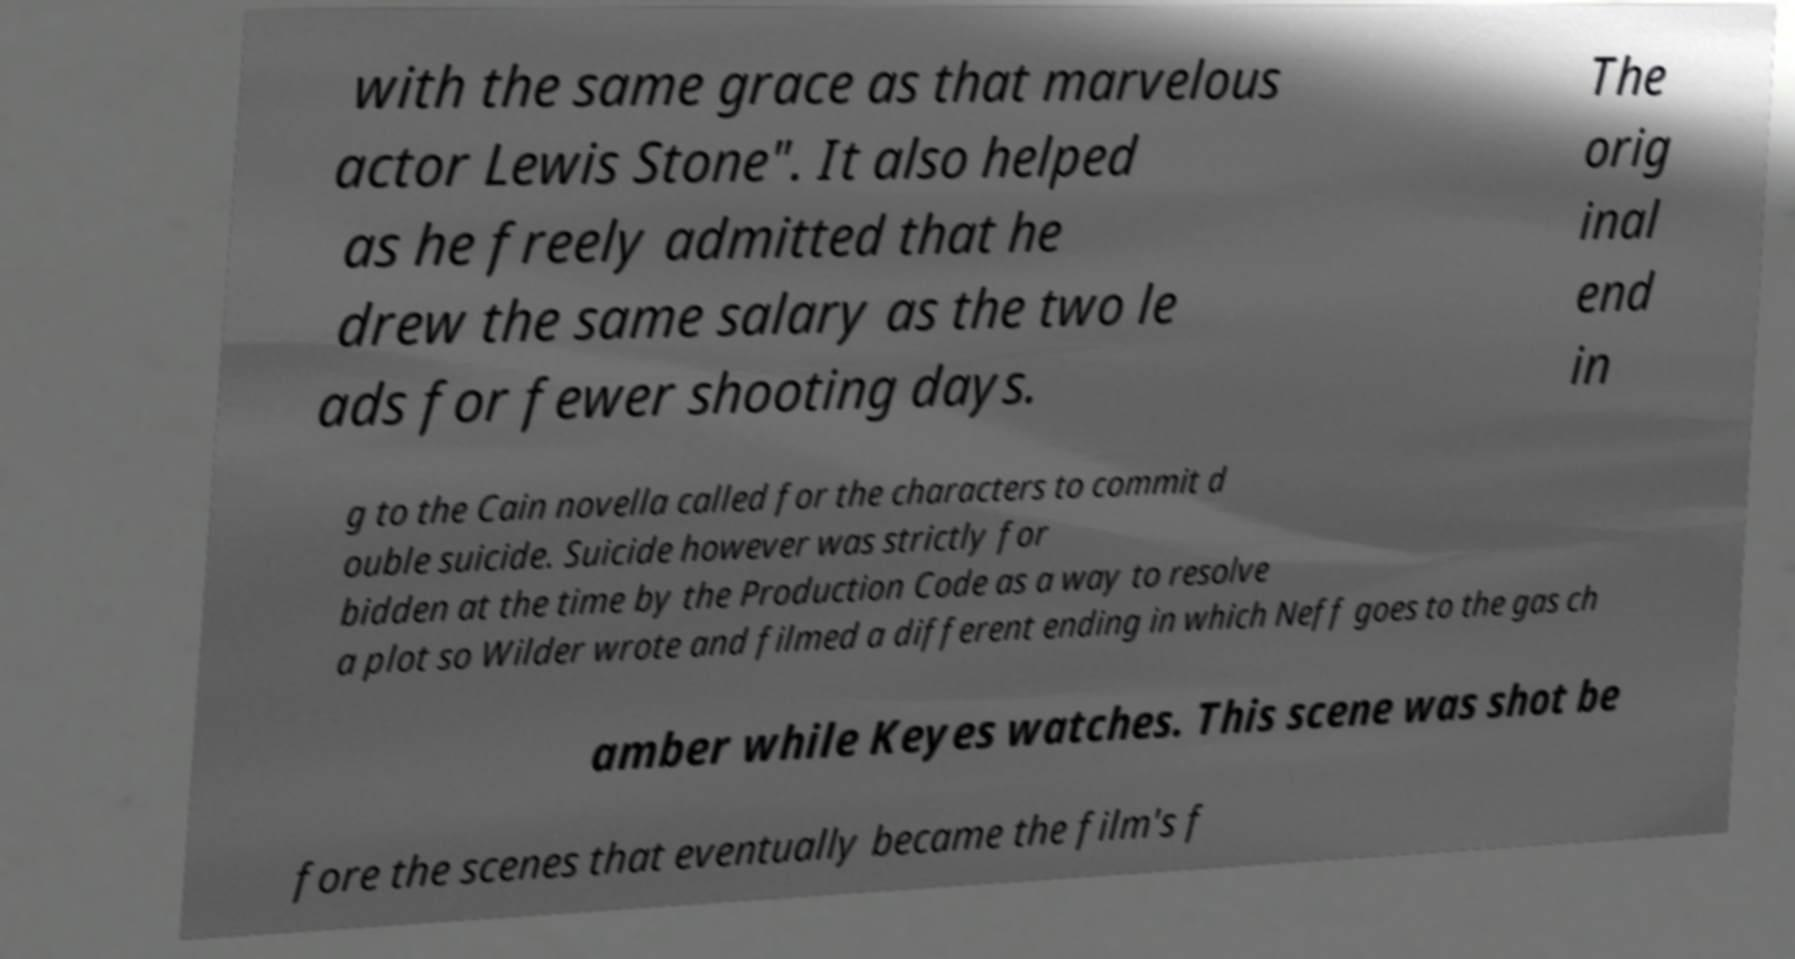What messages or text are displayed in this image? I need them in a readable, typed format. with the same grace as that marvelous actor Lewis Stone". It also helped as he freely admitted that he drew the same salary as the two le ads for fewer shooting days. The orig inal end in g to the Cain novella called for the characters to commit d ouble suicide. Suicide however was strictly for bidden at the time by the Production Code as a way to resolve a plot so Wilder wrote and filmed a different ending in which Neff goes to the gas ch amber while Keyes watches. This scene was shot be fore the scenes that eventually became the film's f 